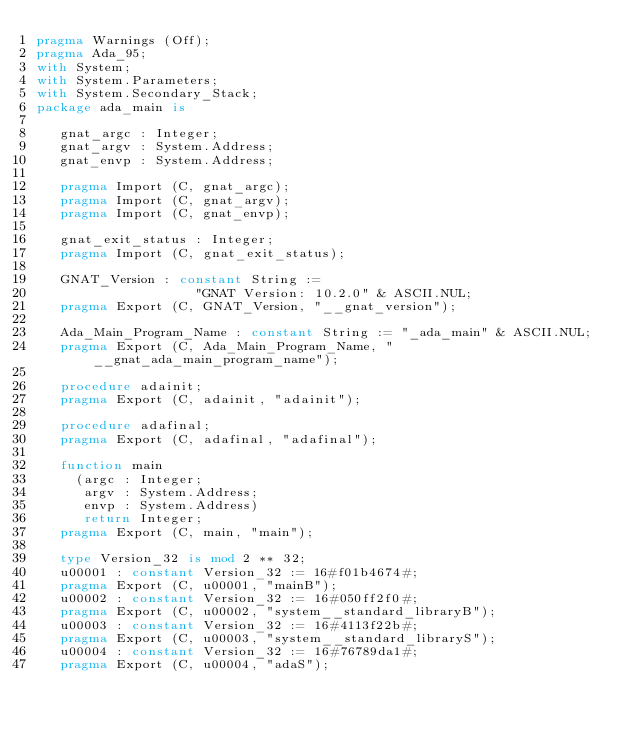<code> <loc_0><loc_0><loc_500><loc_500><_Ada_>pragma Warnings (Off);
pragma Ada_95;
with System;
with System.Parameters;
with System.Secondary_Stack;
package ada_main is

   gnat_argc : Integer;
   gnat_argv : System.Address;
   gnat_envp : System.Address;

   pragma Import (C, gnat_argc);
   pragma Import (C, gnat_argv);
   pragma Import (C, gnat_envp);

   gnat_exit_status : Integer;
   pragma Import (C, gnat_exit_status);

   GNAT_Version : constant String :=
                    "GNAT Version: 10.2.0" & ASCII.NUL;
   pragma Export (C, GNAT_Version, "__gnat_version");

   Ada_Main_Program_Name : constant String := "_ada_main" & ASCII.NUL;
   pragma Export (C, Ada_Main_Program_Name, "__gnat_ada_main_program_name");

   procedure adainit;
   pragma Export (C, adainit, "adainit");

   procedure adafinal;
   pragma Export (C, adafinal, "adafinal");

   function main
     (argc : Integer;
      argv : System.Address;
      envp : System.Address)
      return Integer;
   pragma Export (C, main, "main");

   type Version_32 is mod 2 ** 32;
   u00001 : constant Version_32 := 16#f01b4674#;
   pragma Export (C, u00001, "mainB");
   u00002 : constant Version_32 := 16#050ff2f0#;
   pragma Export (C, u00002, "system__standard_libraryB");
   u00003 : constant Version_32 := 16#4113f22b#;
   pragma Export (C, u00003, "system__standard_libraryS");
   u00004 : constant Version_32 := 16#76789da1#;
   pragma Export (C, u00004, "adaS");</code> 